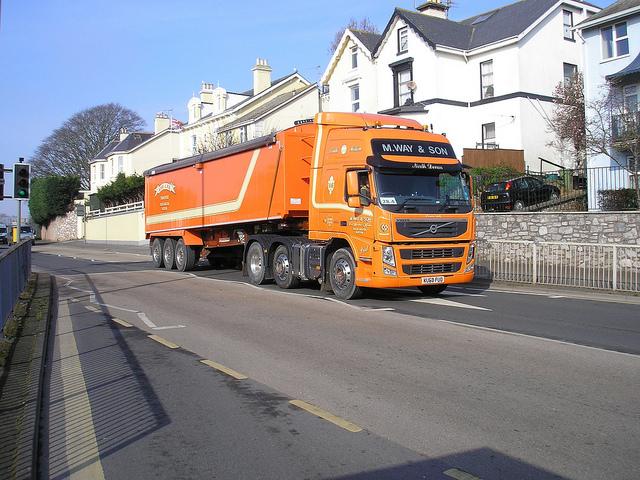What color is the truck?
Quick response, please. Orange. What color is the road?
Be succinct. Gray. Is the area a city?
Keep it brief. Yes. 